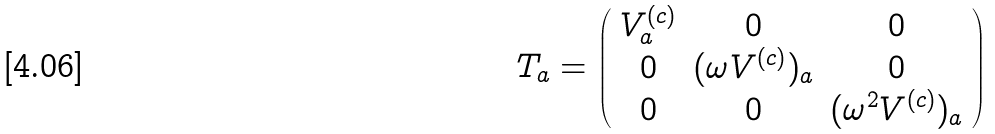<formula> <loc_0><loc_0><loc_500><loc_500>T _ { a } = \left ( \begin{array} { c c c } { { V _ { a } ^ { ( c ) } } } & { 0 } & { 0 } \\ { 0 } & { { ( \omega V ^ { ( c ) } ) _ { a } } } & { 0 } \\ { 0 } & { 0 } & { { ( \omega ^ { 2 } V ^ { ( c ) } ) _ { a } } } \end{array} \right )</formula> 